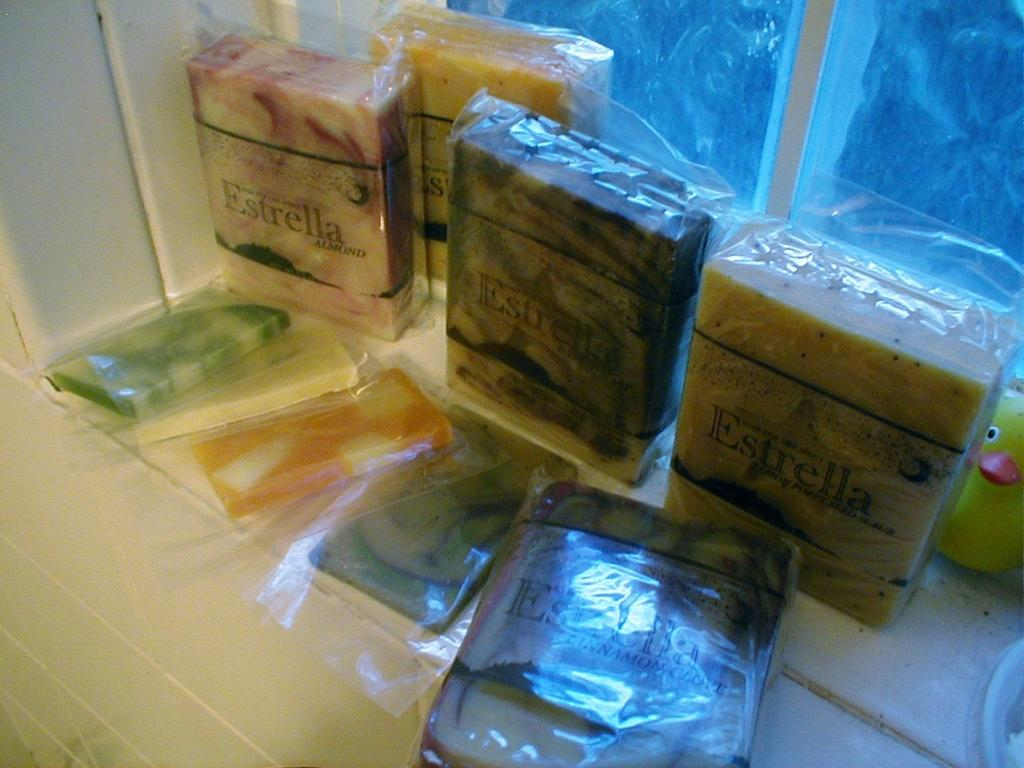What objects are present in the image? There are some packets and a toy in the image. Can you describe the background of the image? There is a window in the background of the image. What is the structure visible at the bottom and on the left side of the image? There is a wall at the bottom and on the left side of the image. What type of poison is being used in the park in the image? There is no park or poison present in the image. 